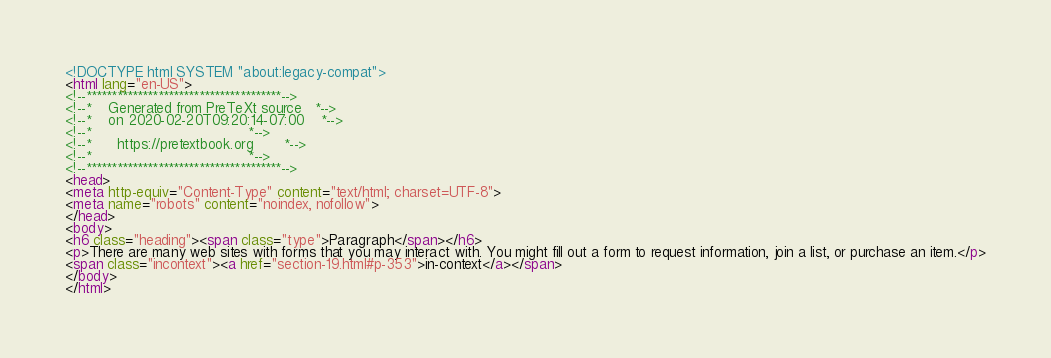<code> <loc_0><loc_0><loc_500><loc_500><_HTML_><!DOCTYPE html SYSTEM "about:legacy-compat">
<html lang="en-US">
<!--**************************************-->
<!--*    Generated from PreTeXt source   *-->
<!--*    on 2020-02-20T09:20:14-07:00    *-->
<!--*                                    *-->
<!--*      https://pretextbook.org       *-->
<!--*                                    *-->
<!--**************************************-->
<head>
<meta http-equiv="Content-Type" content="text/html; charset=UTF-8">
<meta name="robots" content="noindex, nofollow">
</head>
<body>
<h6 class="heading"><span class="type">Paragraph</span></h6>
<p>There are many web sites with forms that you may interact with. You might fill out a form to request information, join a list, or purchase an item.</p>
<span class="incontext"><a href="section-19.html#p-353">in-context</a></span>
</body>
</html>
</code> 